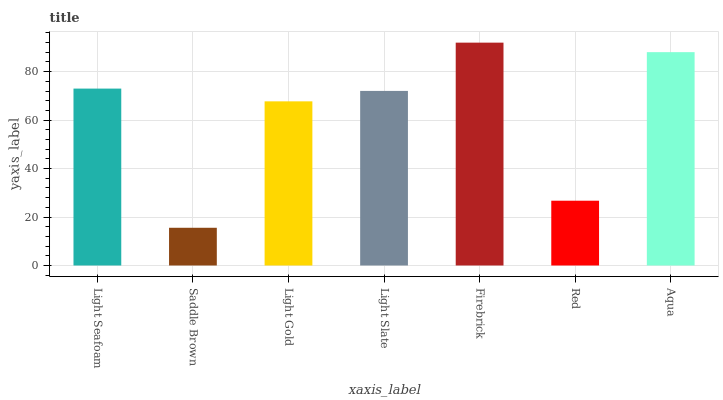Is Saddle Brown the minimum?
Answer yes or no. Yes. Is Firebrick the maximum?
Answer yes or no. Yes. Is Light Gold the minimum?
Answer yes or no. No. Is Light Gold the maximum?
Answer yes or no. No. Is Light Gold greater than Saddle Brown?
Answer yes or no. Yes. Is Saddle Brown less than Light Gold?
Answer yes or no. Yes. Is Saddle Brown greater than Light Gold?
Answer yes or no. No. Is Light Gold less than Saddle Brown?
Answer yes or no. No. Is Light Slate the high median?
Answer yes or no. Yes. Is Light Slate the low median?
Answer yes or no. Yes. Is Firebrick the high median?
Answer yes or no. No. Is Saddle Brown the low median?
Answer yes or no. No. 